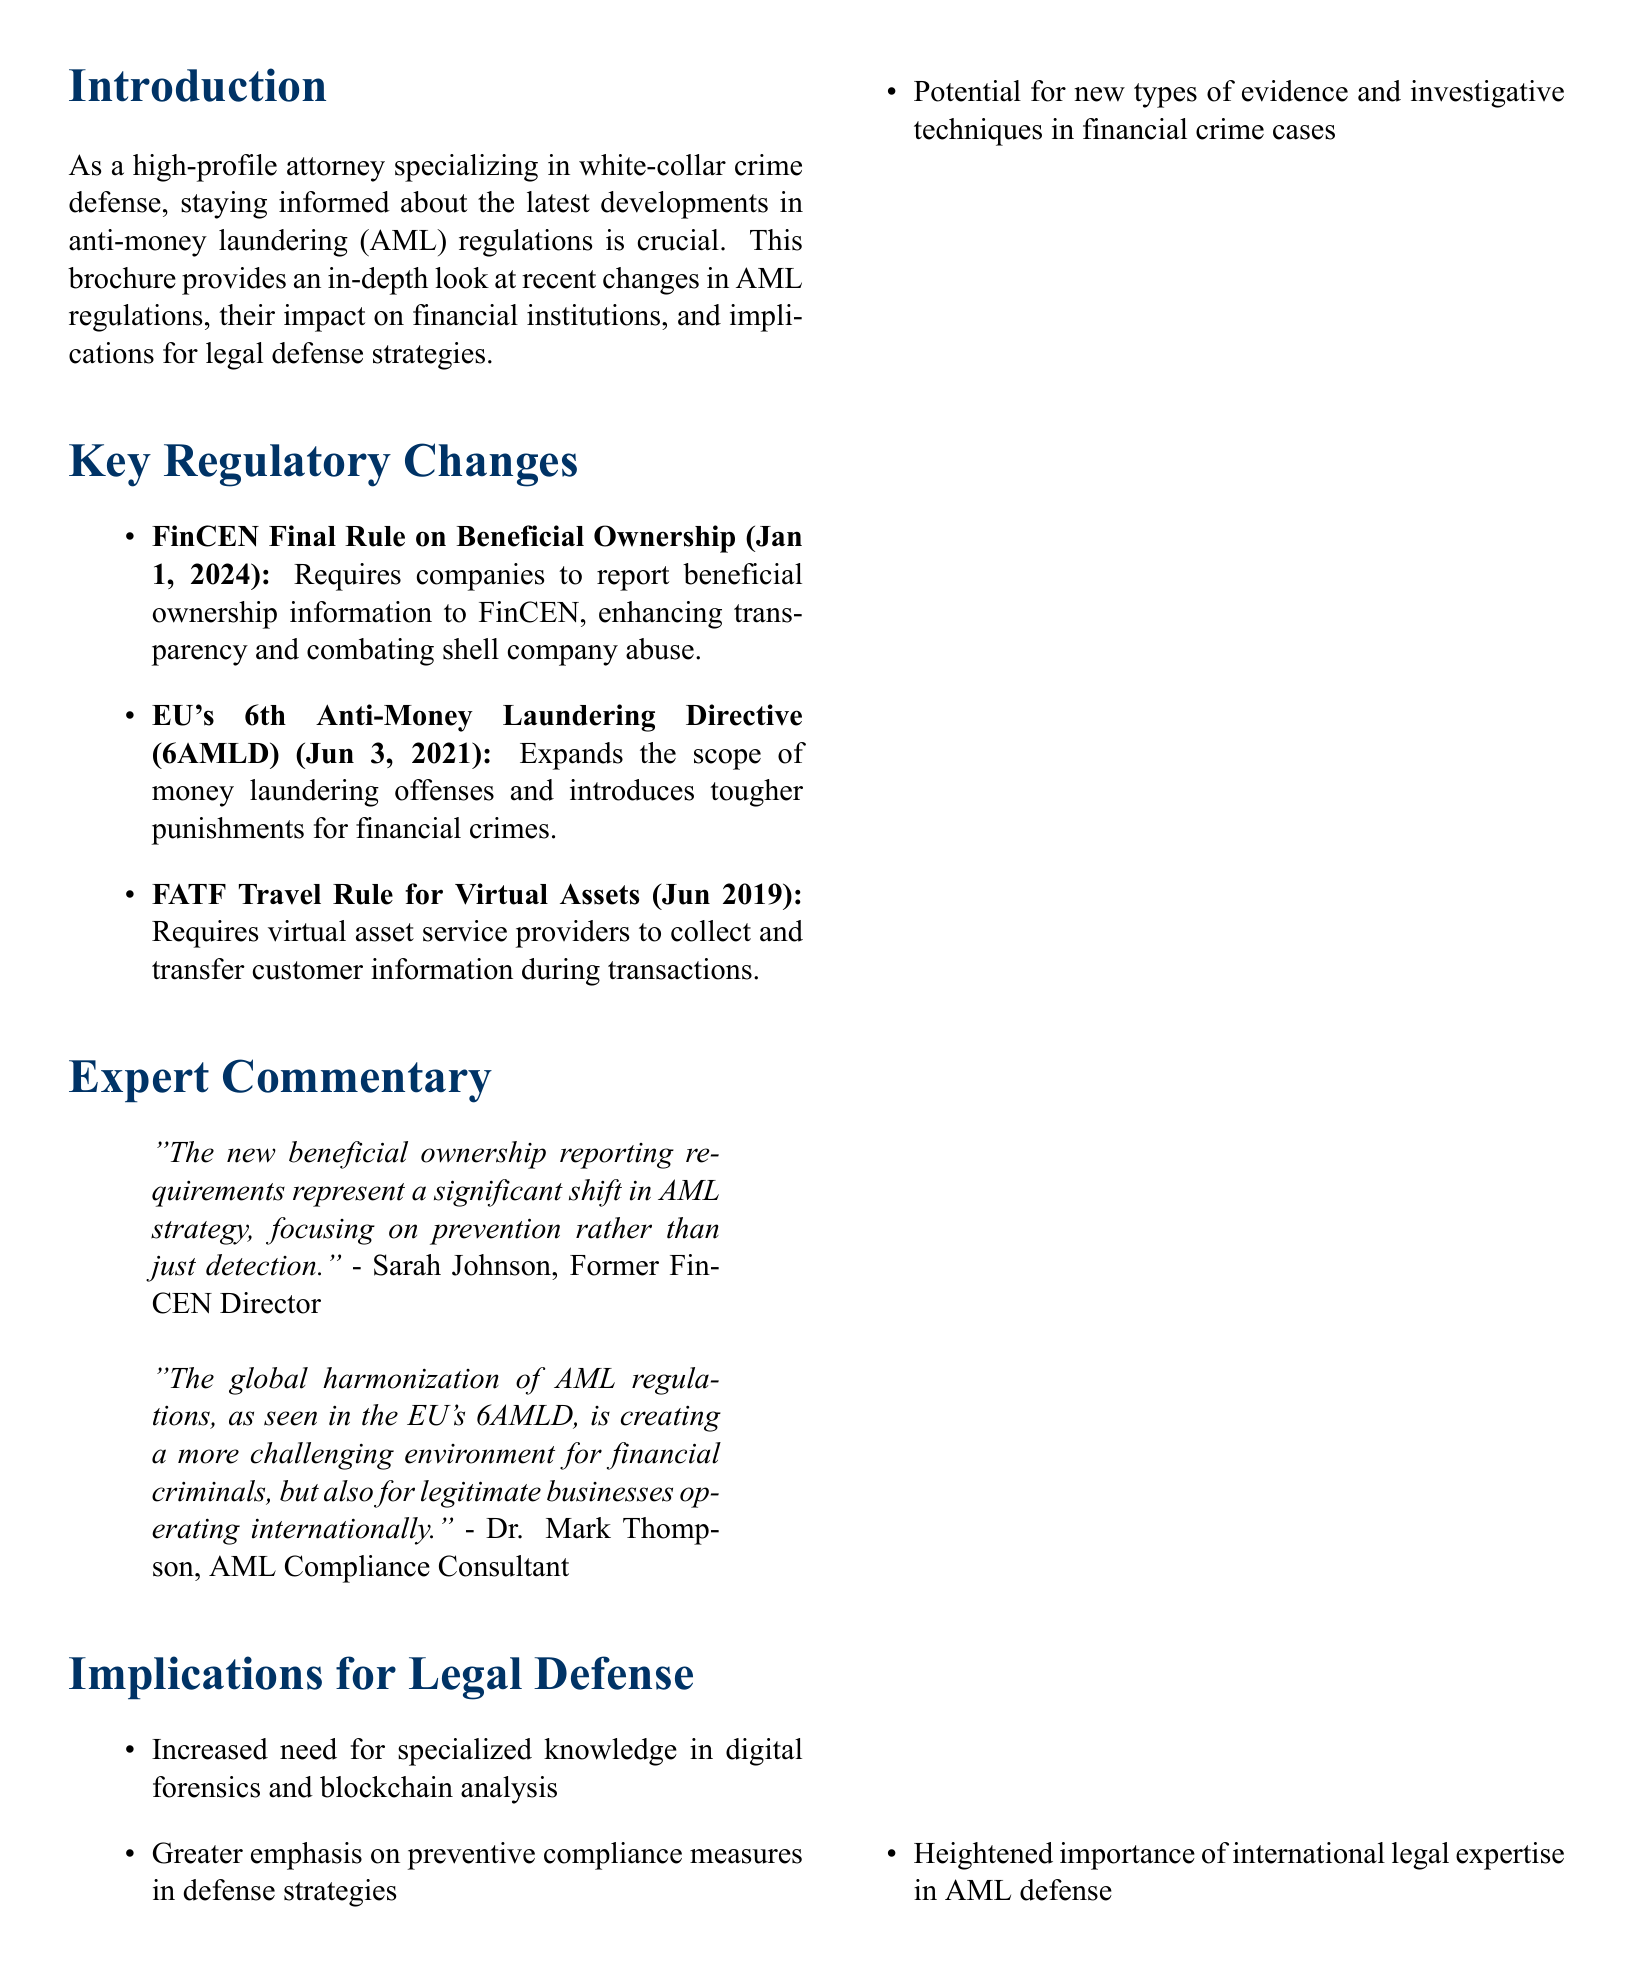What is the title of the brochure? The title of the brochure is specified at the beginning of the document.
Answer: Recent Changes in Anti-Money Laundering Regulations: A Comprehensive Overview When does the FinCEN Final Rule on Beneficial Ownership take effect? The effective date is mentioned under key regulatory changes.
Answer: January 1, 2024 What does the EU's 6th Anti-Money Laundering Directive (6AMLD) introduce? The document describes the changes that come with 6AMLD in the regulatory changes section.
Answer: Tougher punishments for financial crimes Who is quoted as saying the new beneficial ownership reporting requirements represent a significant shift in AML strategy? This information is provided in the expert commentary section of the document.
Answer: Sarah Johnson What is one implication for legal defense mentioned in the brochure? The implications for legal defense are listed, highlighting various needs and changes.
Answer: Increased need for specialized knowledge in digital forensics and blockchain analysis What was the event that occurred in September 2022? The timeline lists significant AML events and their corresponding dates.
Answer: FinCEN issues Final Rule on Beneficial Ownership Information Reporting What type of document is this? The structure and content indicate its purpose and form.
Answer: Brochure What is the primary focus of the brochure? The introduction outlines the main purpose of the brochure in a clear statement.
Answer: Recent changes in AML regulations 